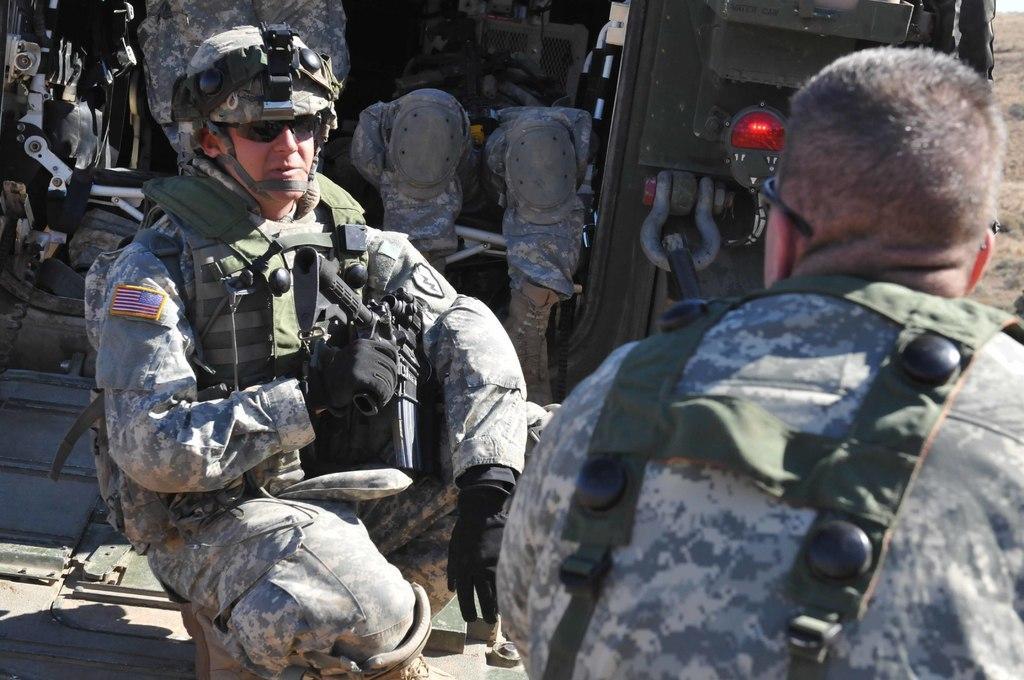Can you describe this image briefly? In this image I can see two persons wearing military uniforms and black colored gloves are sitting on the ground. In the background I can see a vehicle and few persons in the vehicle. 